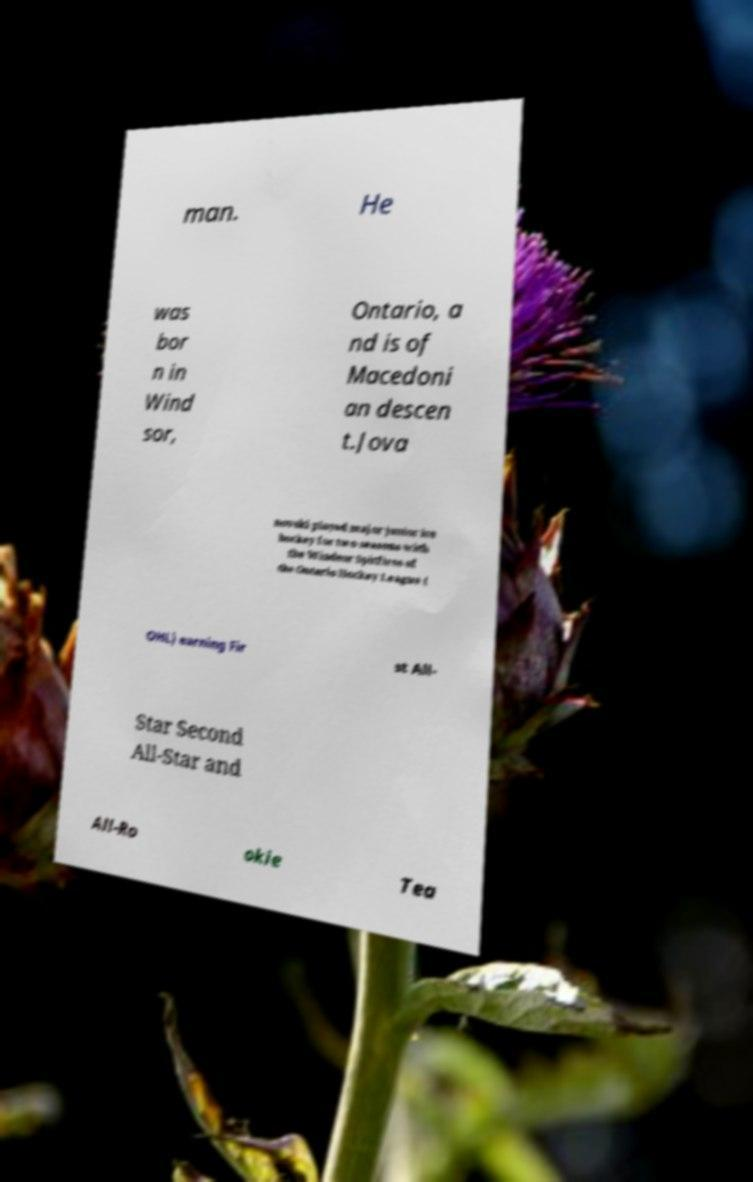What messages or text are displayed in this image? I need them in a readable, typed format. man. He was bor n in Wind sor, Ontario, a nd is of Macedoni an descen t.Jova novski played major junior ice hockey for two seasons with the Windsor Spitfires of the Ontario Hockey League ( OHL) earning Fir st All- Star Second All-Star and All-Ro okie Tea 